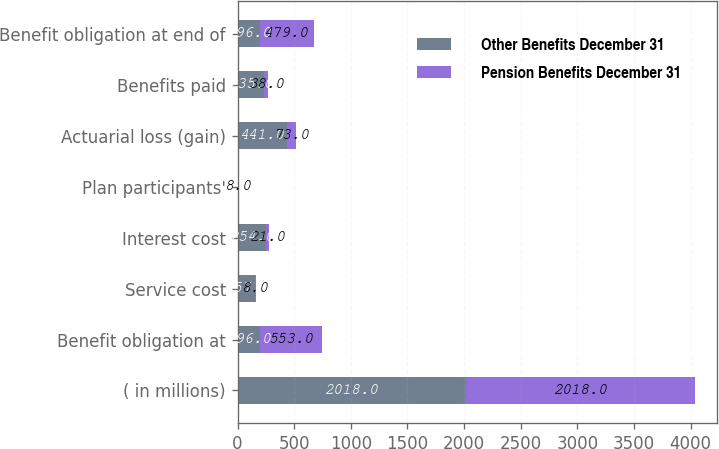<chart> <loc_0><loc_0><loc_500><loc_500><stacked_bar_chart><ecel><fcel>( in millions)<fcel>Benefit obligation at<fcel>Service cost<fcel>Interest cost<fcel>Plan participants'<fcel>Actuarial loss (gain)<fcel>Benefits paid<fcel>Benefit obligation at end of<nl><fcel>Other Benefits December 31<fcel>2018<fcel>196<fcel>157<fcel>254<fcel>6<fcel>441<fcel>235<fcel>196<nl><fcel>Pension Benefits December 31<fcel>2018<fcel>553<fcel>8<fcel>21<fcel>8<fcel>73<fcel>38<fcel>479<nl></chart> 